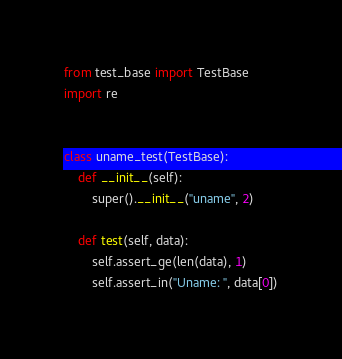Convert code to text. <code><loc_0><loc_0><loc_500><loc_500><_Python_>from test_base import TestBase
import re


class uname_test(TestBase):
    def __init__(self):
        super().__init__("uname", 2)

    def test(self, data):
        self.assert_ge(len(data), 1)
        self.assert_in("Uname: ", data[0])
</code> 